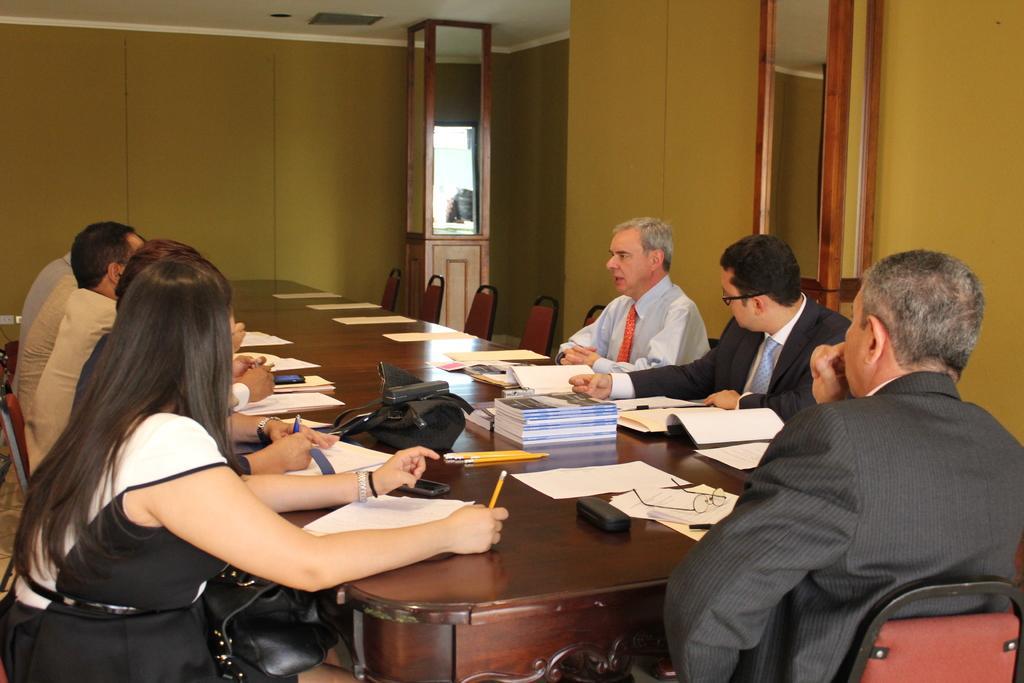How would you summarize this image in a sentence or two? In this picture I can see few people sitting on the chairs and I can see papers, few books, spectacles and couple of mobiles on the table and I can see a hand bag on the woman´s lap and I can see mirrors. 